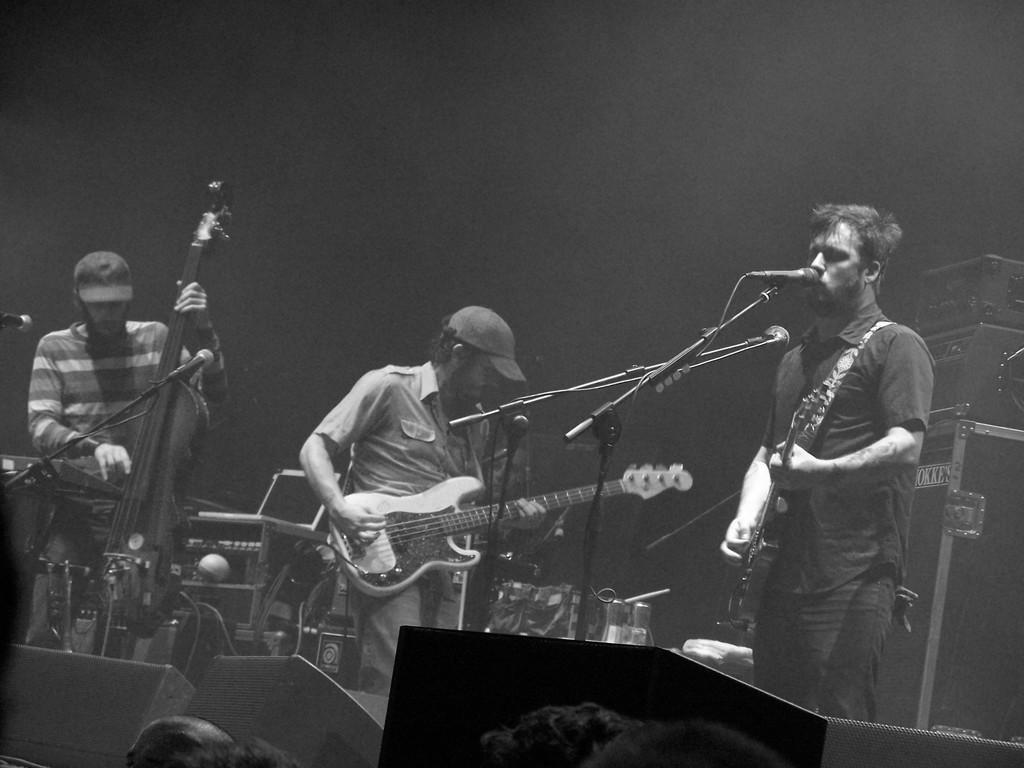In one or two sentences, can you explain what this image depicts? There are group of man standing in front of microphone and playing musical instruments. 